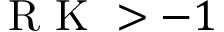Convert formula to latex. <formula><loc_0><loc_0><loc_500><loc_500>R K > - 1</formula> 